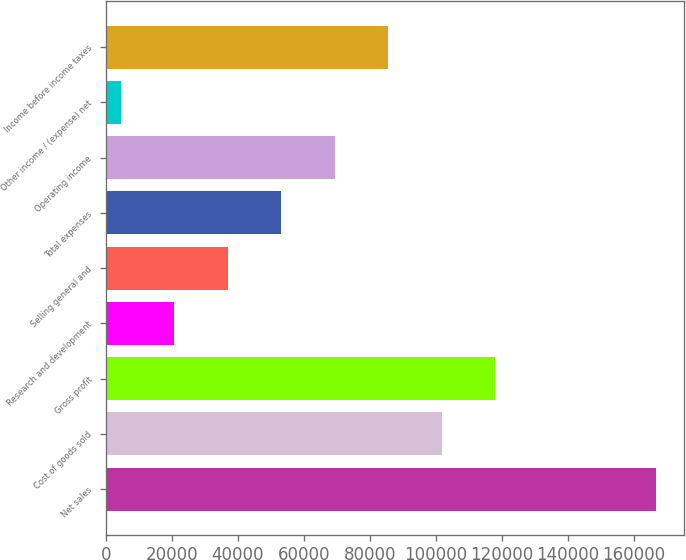Convert chart. <chart><loc_0><loc_0><loc_500><loc_500><bar_chart><fcel>Net sales<fcel>Cost of goods sold<fcel>Gross profit<fcel>Research and development<fcel>Selling general and<fcel>Total expenses<fcel>Operating income<fcel>Other income / (expense) net<fcel>Income before income taxes<nl><fcel>166639<fcel>101809<fcel>118016<fcel>20770.6<fcel>36978.2<fcel>53185.8<fcel>69393.4<fcel>4563<fcel>85601<nl></chart> 